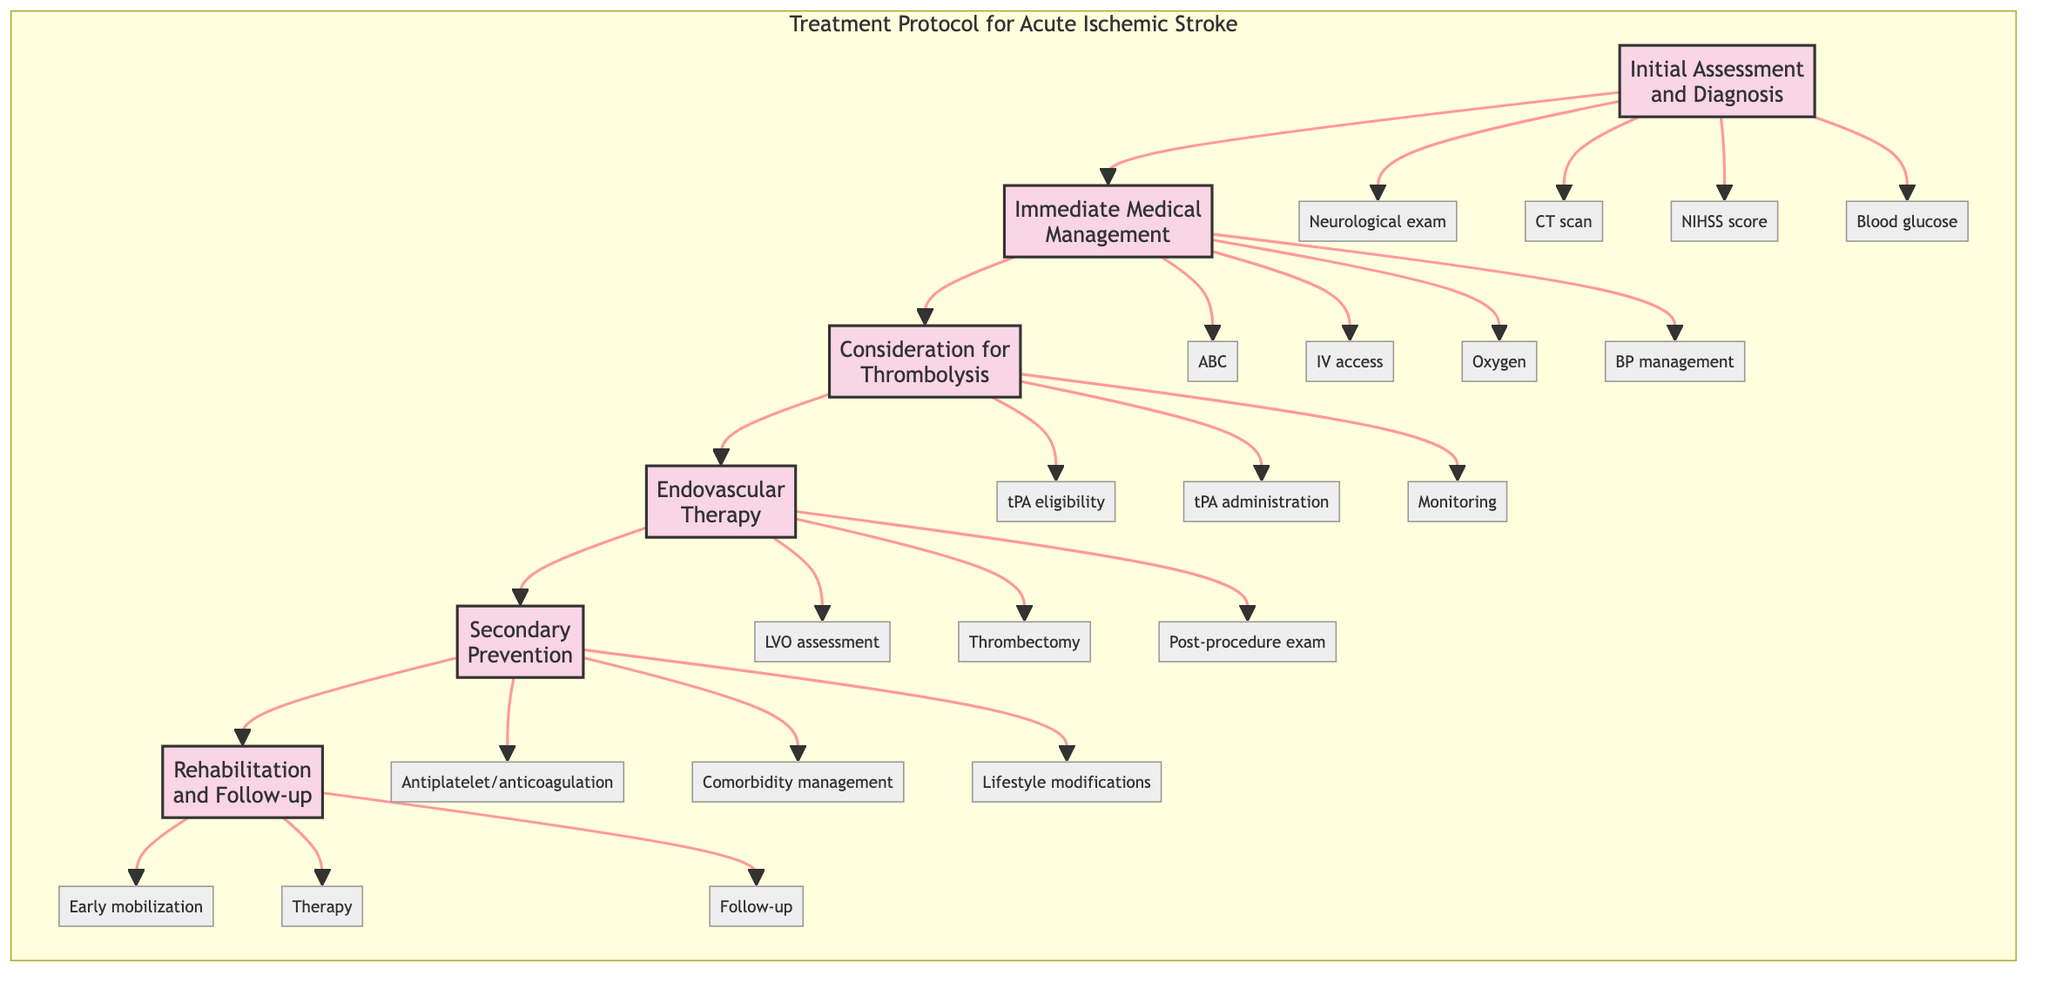What is the first step in the treatment protocol? The diagram lists "Initial Assessment and Diagnosis" as the first step, indicating that this is the starting point of the treatment protocol.
Answer: Initial Assessment and Diagnosis How many steps are there in the treatment protocol? The diagram outlines a total of six steps, which can be counted from the flowchart's structure: Initial Assessment and Diagnosis, Immediate Medical Management, Consideration for Thrombolysis, Endovascular Therapy, Secondary Prevention, and Rehabilitation and Follow-up.
Answer: 6 What follows Immediate Medical Management? According to the flow of the diagram, "Consideration for Thrombolysis" directly follows "Immediate Medical Management," as it is the next step in the sequence.
Answer: Consideration for Thrombolysis What is one element of endovascular therapy? The diagram specifies "Assess for large vessel occlusion (LVO)" as one element under the step "Endovascular Therapy," which is essential to determine if this therapy is needed.
Answer: Assess for large vessel occlusion (LVO) Which step involves the administration of IV tPA? The step "Consideration for Thrombolysis" specifically includes the action of administering IV tPA, directly addressing thrombolysis treatment for acute ischemic stroke.
Answer: Consideration for Thrombolysis How does the diagram structure the treatment process? The diagram is structured in a linear fashion where each step consecutively leads to the next, indicating a clear pathway from initial assessment to rehabilitation and follow-up.
Answer: Linear pathway What type of therapy is initiated during secondary prevention? The diagram mentions "Initiate antiplatelet or anticoagulation therapy" as part of "Secondary Prevention," which focuses on preventing future strokes through medication management.
Answer: Antiplatelet or anticoagulation therapy What must be monitored after administering IV tPA? The diagram indicates "Monitor for signs of bleeding or other complications" as a critical task after administering IV tPA in the "Consideration for Thrombolysis" step.
Answer: Signs of bleeding or other complications What is the final step in the treatment pathway? The diagram shows that "Rehabilitation and Follow-up" is the final step in the treatment protocol for acute ischemic stroke, concluding the structured approach.
Answer: Rehabilitation and Follow-up 